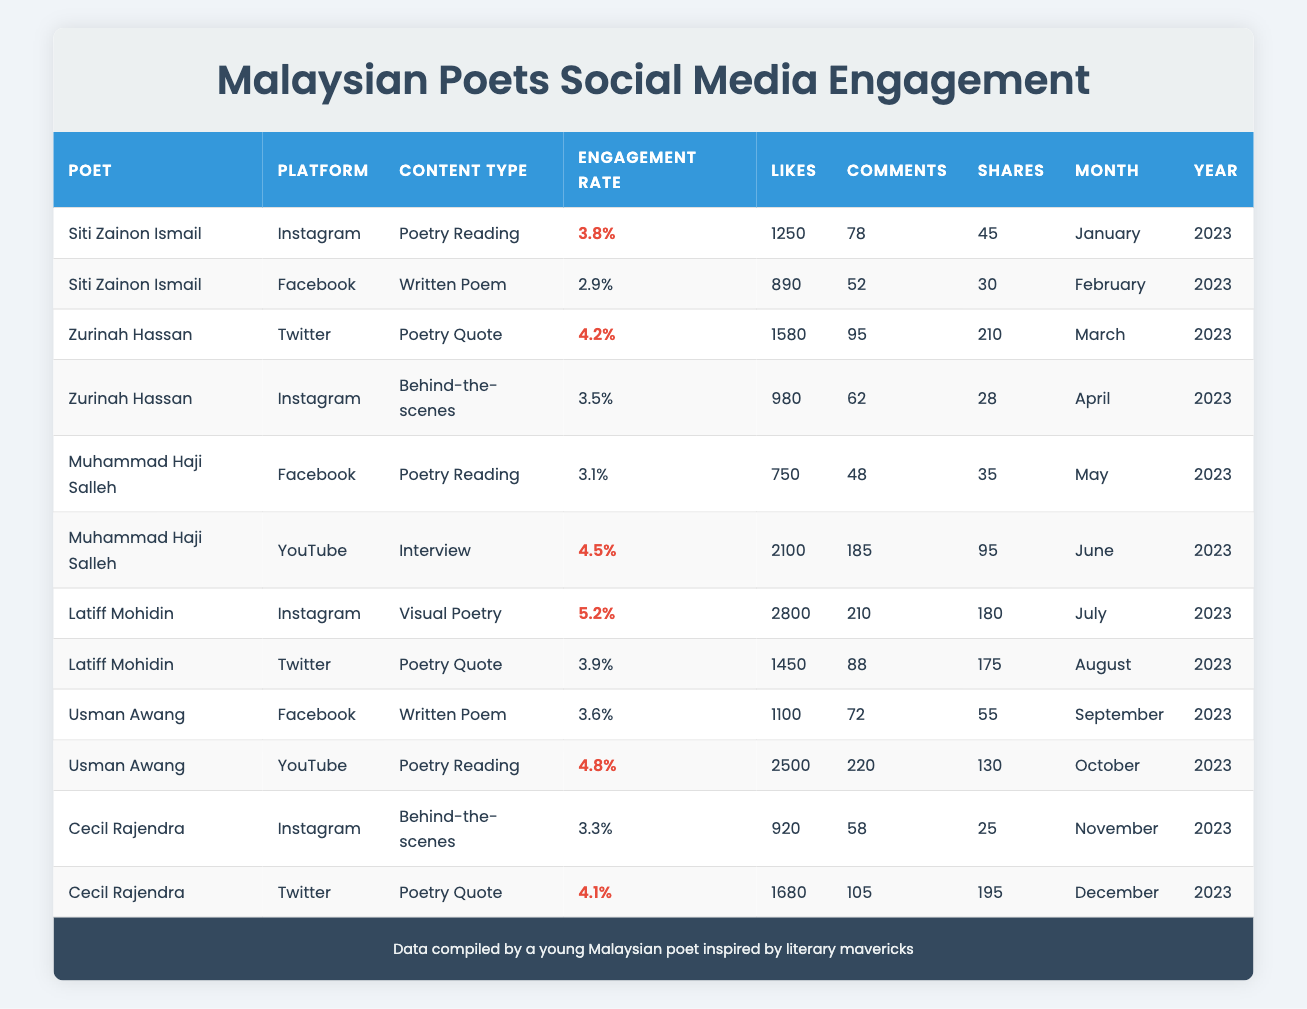What is the highest engagement rate among the poets listed? By looking at the Engagement Rate column in the table, we find that Latiff Mohidin has the highest engagement rate of 5.2% in July 2023 for his Visual Poetry content on Instagram.
Answer: 5.2% Which poet received the most likes in June 2023? In June 2023, Muhammad Haji Salleh received the most likes (2100) for his Interview content on YouTube.
Answer: 2100 How many total shares did Usman Awang receive across both of his listed posts? Usman Awang has two posts: one on Facebook with 55 shares and one on YouTube with 130 shares. Adding these gives us 55 + 130 = 185 shares in total.
Answer: 185 Did Siti Zainon Ismail have a higher engagement rate on Instagram or Facebook? Siti Zainon Ismail's engagement rate on Instagram is 3.8% and on Facebook is 2.9%. Since 3.8% is greater than 2.9%, her engagement rate on Instagram is higher.
Answer: Yes What is the average engagement rate of the poets for their Instagram posts? There are three poets who posted on Instagram: Siti Zainon Ismail (3.8%), Zurinah Hassan (3.5%), and Latiff Mohidin (5.2%). Adding these rates gives 3.8 + 3.5 + 5.2 = 12.5. Dividing by the number of poets (3) results in an average engagement rate of 12.5 / 3 = 4.17%.
Answer: 4.17% 